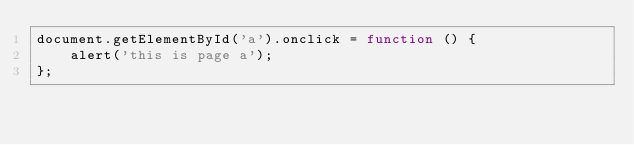Convert code to text. <code><loc_0><loc_0><loc_500><loc_500><_JavaScript_>document.getElementById('a').onclick = function () {
    alert('this is page a');
};
</code> 